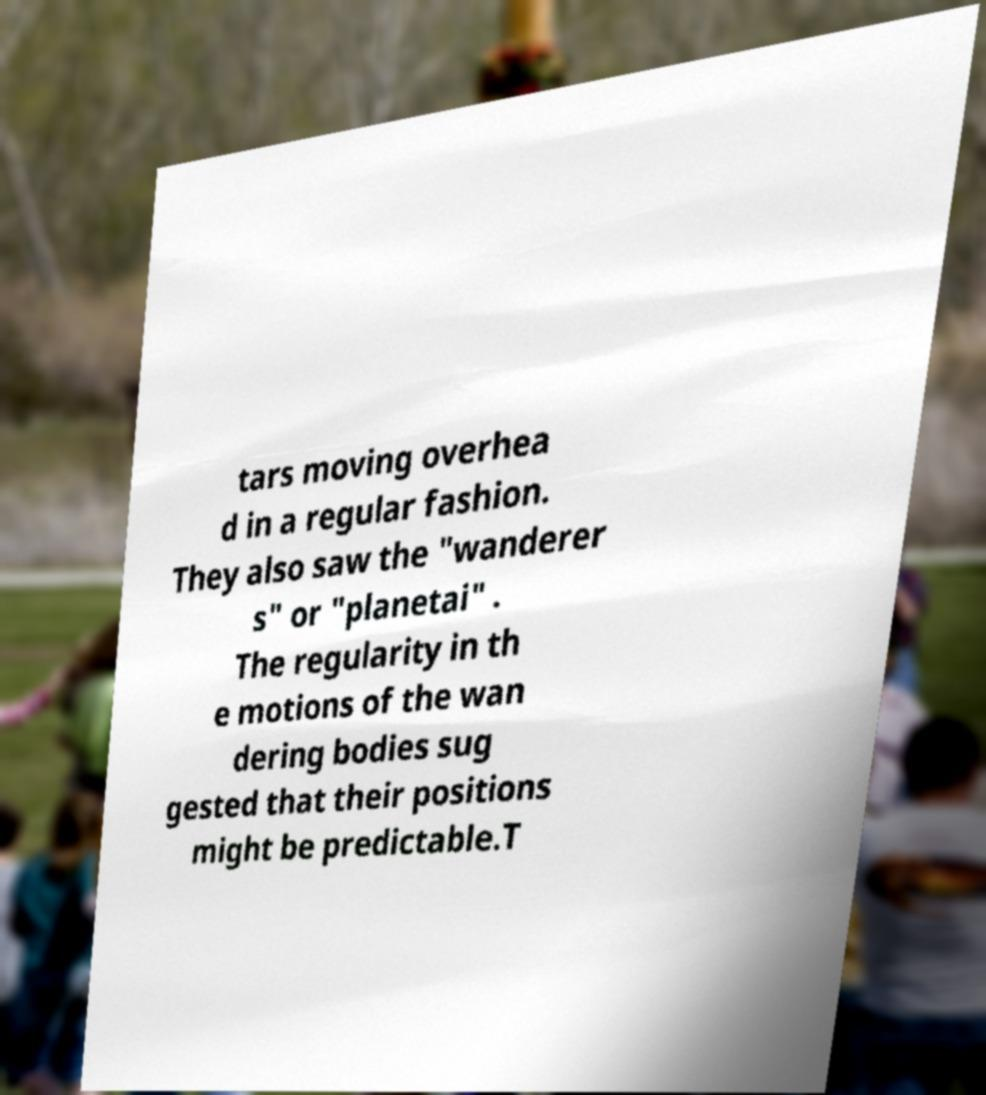Please identify and transcribe the text found in this image. tars moving overhea d in a regular fashion. They also saw the "wanderer s" or "planetai" . The regularity in th e motions of the wan dering bodies sug gested that their positions might be predictable.T 